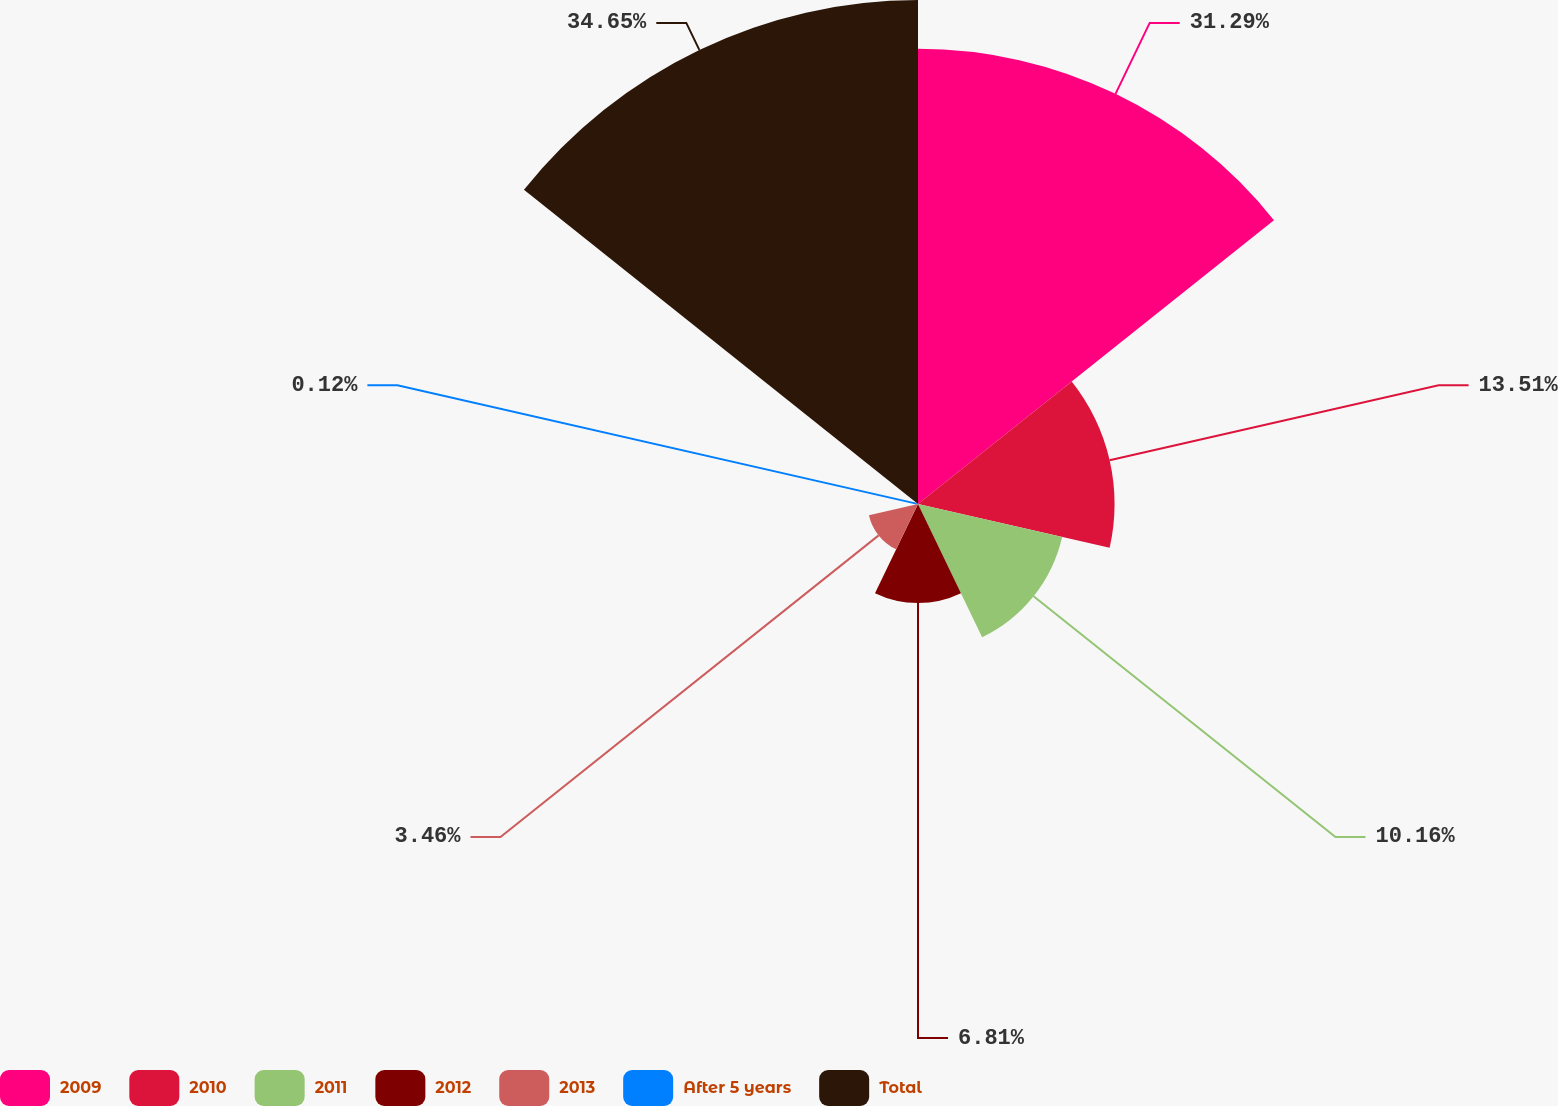<chart> <loc_0><loc_0><loc_500><loc_500><pie_chart><fcel>2009<fcel>2010<fcel>2011<fcel>2012<fcel>2013<fcel>After 5 years<fcel>Total<nl><fcel>31.29%<fcel>13.51%<fcel>10.16%<fcel>6.81%<fcel>3.46%<fcel>0.12%<fcel>34.64%<nl></chart> 